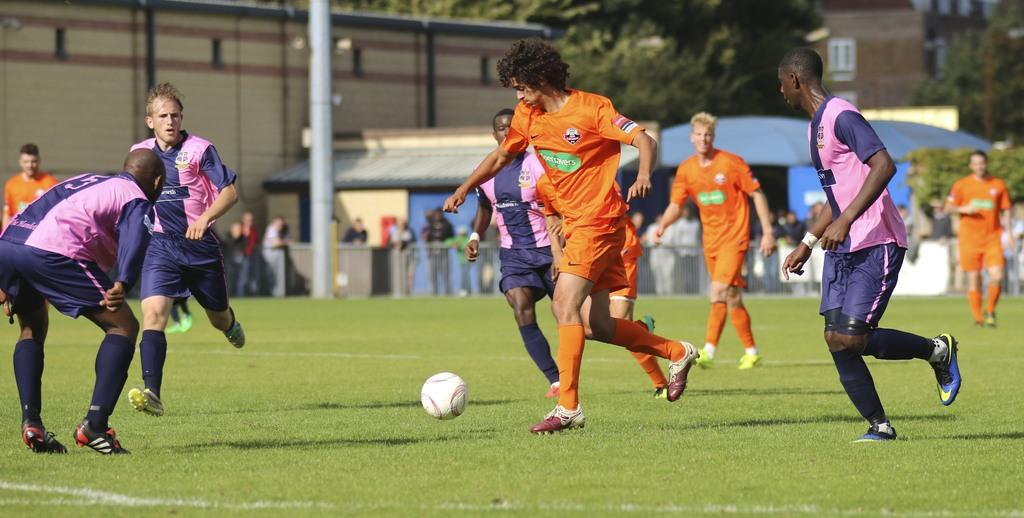What type of vegetation is present in the image? There is grass in the image. What object can be seen in the image that is often used for playing? There is a ball in the image. What are the people in the image doing? People are playing in the image. What can be seen in the distance in the image? There are buildings and people in the background of the image. What type of mailbox is present in the image? There is no mailbox present in the image. How many legs are visible in the image? The number of legs visible in the image cannot be determined, as the image does not show any legs. 